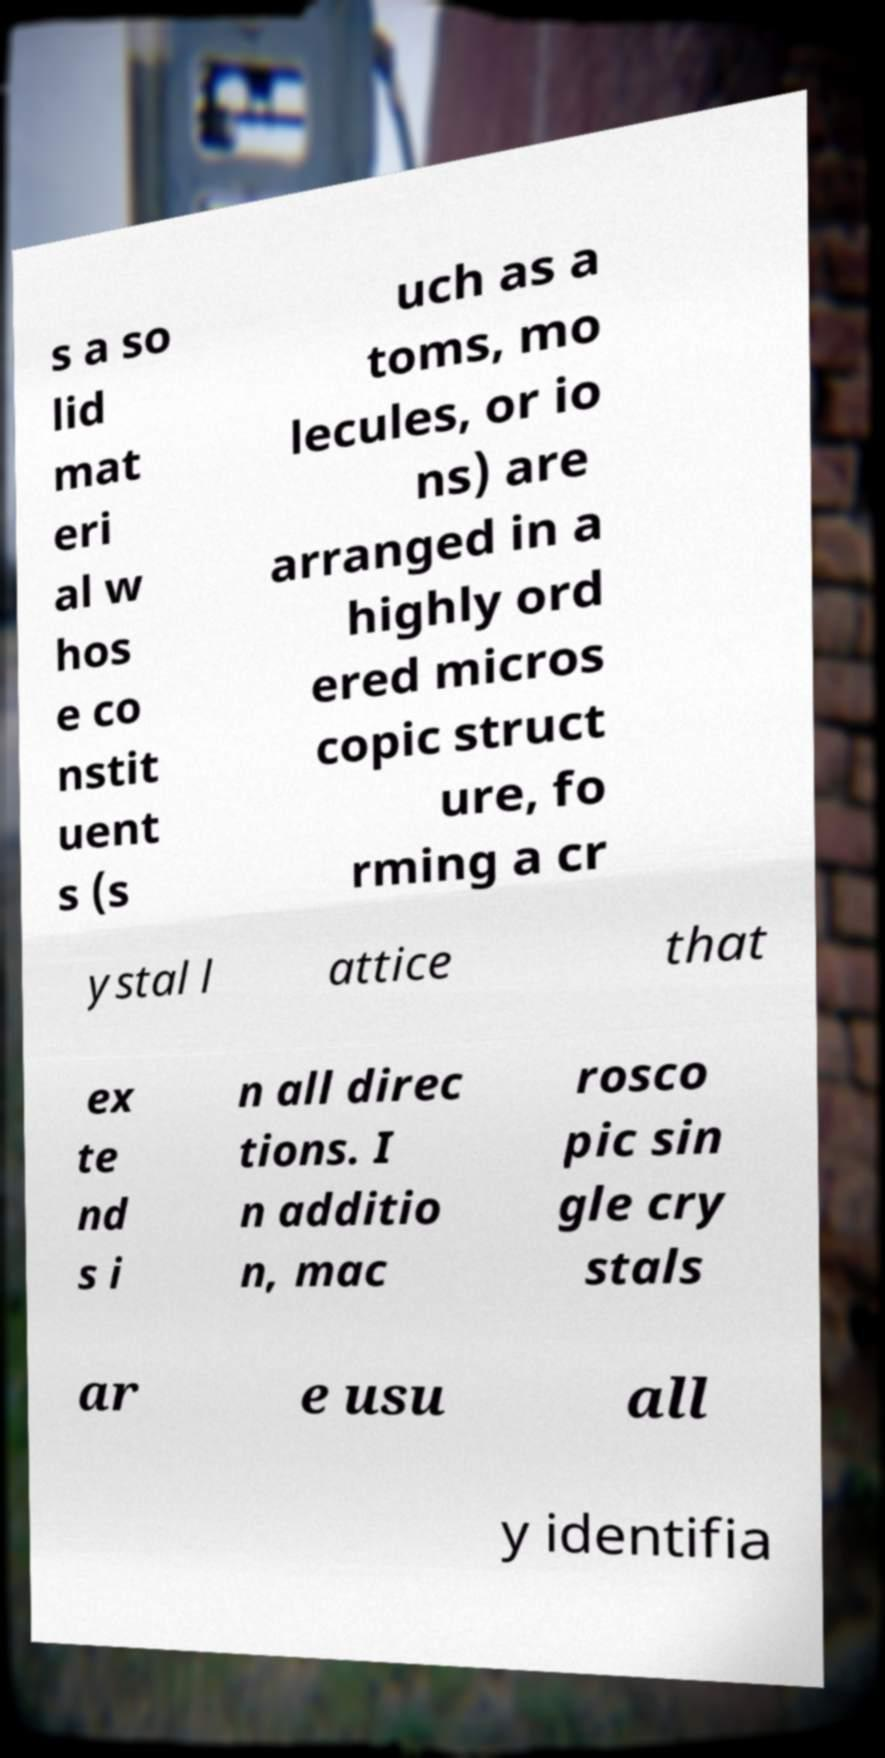Can you accurately transcribe the text from the provided image for me? s a so lid mat eri al w hos e co nstit uent s (s uch as a toms, mo lecules, or io ns) are arranged in a highly ord ered micros copic struct ure, fo rming a cr ystal l attice that ex te nd s i n all direc tions. I n additio n, mac rosco pic sin gle cry stals ar e usu all y identifia 